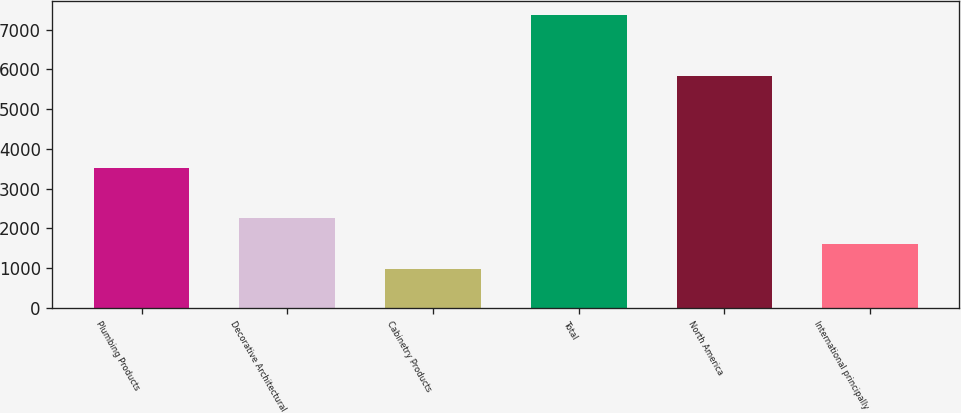Convert chart. <chart><loc_0><loc_0><loc_500><loc_500><bar_chart><fcel>Plumbing Products<fcel>Decorative Architectural<fcel>Cabinetry Products<fcel>Total<fcel>North America<fcel>International principally<nl><fcel>3529<fcel>2248.2<fcel>970<fcel>7361<fcel>5838<fcel>1609.1<nl></chart> 